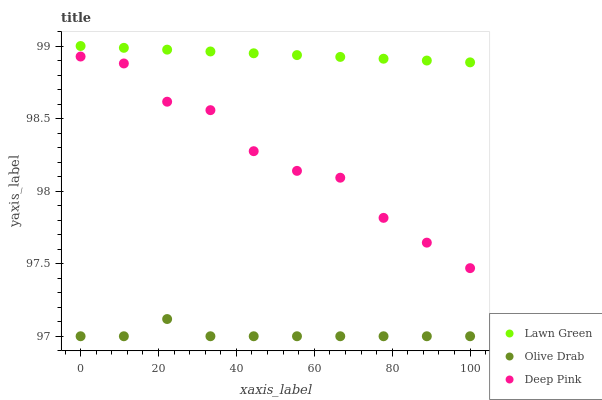Does Olive Drab have the minimum area under the curve?
Answer yes or no. Yes. Does Lawn Green have the maximum area under the curve?
Answer yes or no. Yes. Does Deep Pink have the minimum area under the curve?
Answer yes or no. No. Does Deep Pink have the maximum area under the curve?
Answer yes or no. No. Is Lawn Green the smoothest?
Answer yes or no. Yes. Is Deep Pink the roughest?
Answer yes or no. Yes. Is Olive Drab the smoothest?
Answer yes or no. No. Is Olive Drab the roughest?
Answer yes or no. No. Does Olive Drab have the lowest value?
Answer yes or no. Yes. Does Deep Pink have the lowest value?
Answer yes or no. No. Does Lawn Green have the highest value?
Answer yes or no. Yes. Does Deep Pink have the highest value?
Answer yes or no. No. Is Deep Pink less than Lawn Green?
Answer yes or no. Yes. Is Lawn Green greater than Olive Drab?
Answer yes or no. Yes. Does Deep Pink intersect Lawn Green?
Answer yes or no. No. 